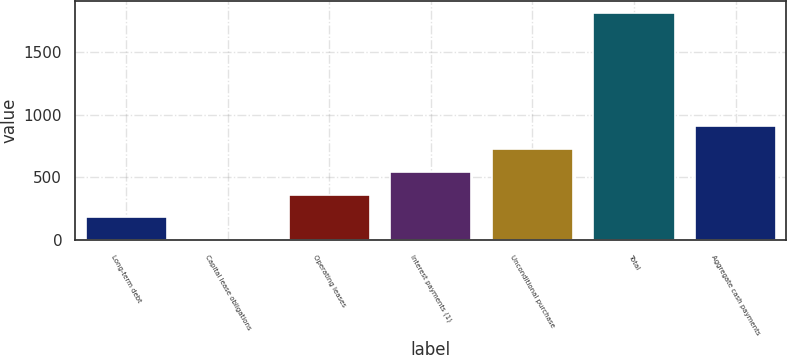Convert chart to OTSL. <chart><loc_0><loc_0><loc_500><loc_500><bar_chart><fcel>Long-term debt<fcel>Capital lease obligations<fcel>Operating leases<fcel>Interest payments (1)<fcel>Unconditional purchase<fcel>Total<fcel>Aggregate cash payments<nl><fcel>182.9<fcel>2<fcel>363.8<fcel>544.7<fcel>725.6<fcel>1811<fcel>906.5<nl></chart> 